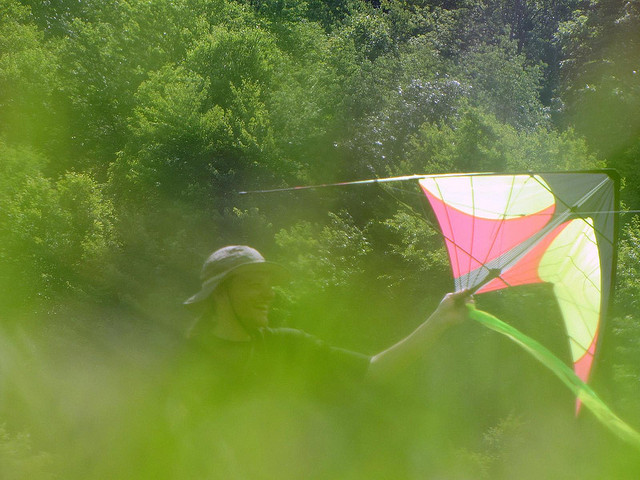<image>Was a filter used to take this photo? I don't know if a filter was used to take this photo. The answers vary between 'yes' and 'no'. Was a filter used to take this photo? I don't know if a filter was used to take this photo. It can be both with or without a filter. 